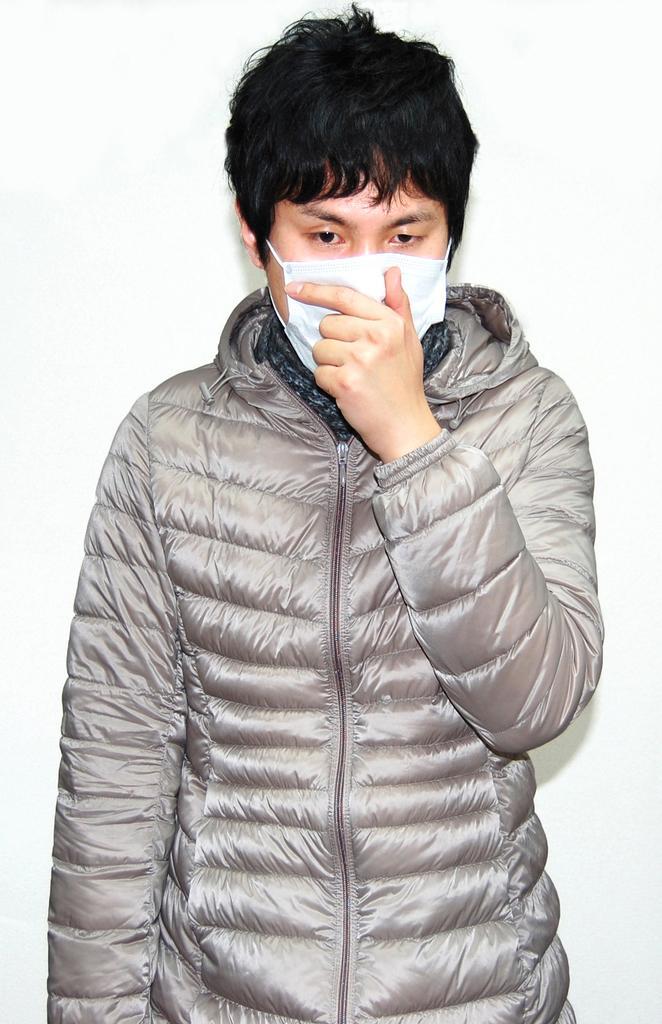Please provide a concise description of this image. In this image in front there is a person wearing a mask. 